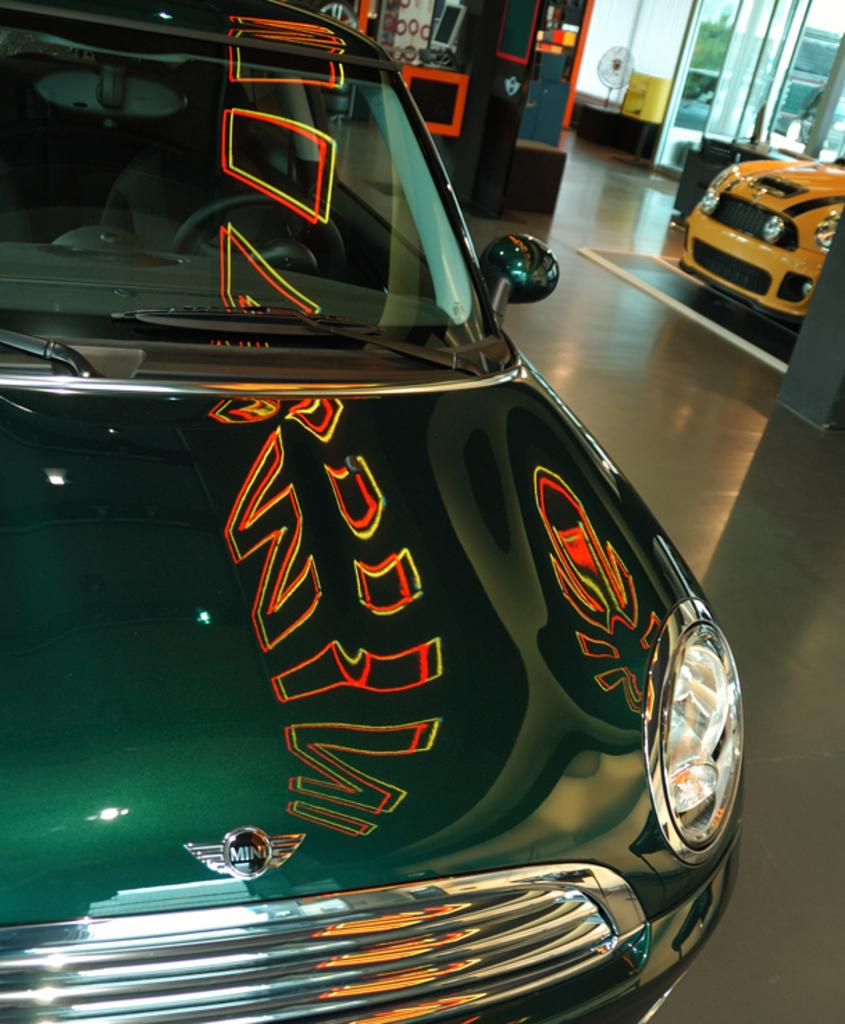What type of vehicles can be seen in the image? There are cars in the image. What objects can be seen in the background of the image? There are glasses and other unspecified things in the background of the image. Is there a stream visible in the image? There is no stream present in the image. 